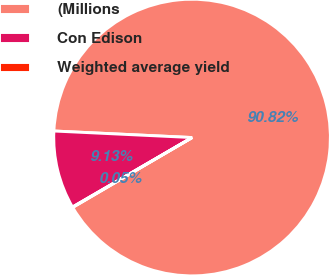<chart> <loc_0><loc_0><loc_500><loc_500><pie_chart><fcel>(Millions<fcel>Con Edison<fcel>Weighted average yield<nl><fcel>90.82%<fcel>9.13%<fcel>0.05%<nl></chart> 